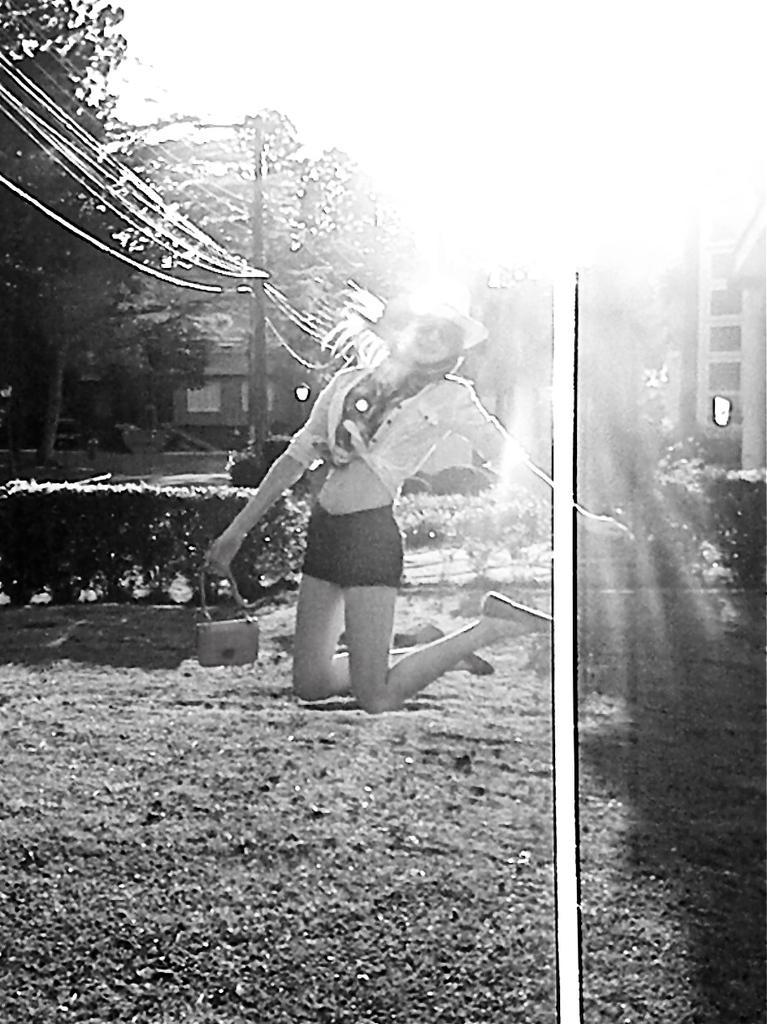Describe this image in one or two sentences. In this image we can see a woman holding a bag. Behind the woman we can see the plants, pole with wires, trees and buildings. In the foreground we can see a white line on the image. At the top we can see the sky. 